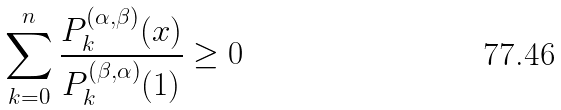Convert formula to latex. <formula><loc_0><loc_0><loc_500><loc_500>\sum _ { k = 0 } ^ { n } \frac { P _ { k } ^ { ( \alpha , \beta ) } ( x ) } { P _ { k } ^ { ( \beta , \alpha ) } ( 1 ) } \geq 0</formula> 